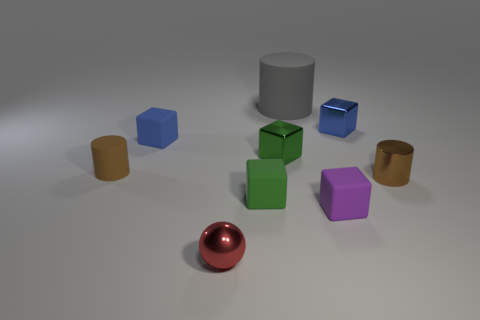Subtract all small blue rubber blocks. How many blocks are left? 4 Subtract 2 blocks. How many blocks are left? 3 Subtract all purple blocks. How many blocks are left? 4 Subtract all gray cubes. Subtract all blue spheres. How many cubes are left? 5 Add 1 matte cubes. How many objects exist? 10 Subtract all blocks. How many objects are left? 4 Add 7 brown matte cylinders. How many brown matte cylinders exist? 8 Subtract 0 cyan spheres. How many objects are left? 9 Subtract all tiny brown things. Subtract all tiny brown rubber cylinders. How many objects are left? 6 Add 8 rubber cylinders. How many rubber cylinders are left? 10 